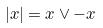Convert formula to latex. <formula><loc_0><loc_0><loc_500><loc_500>| x | = x \vee - x</formula> 